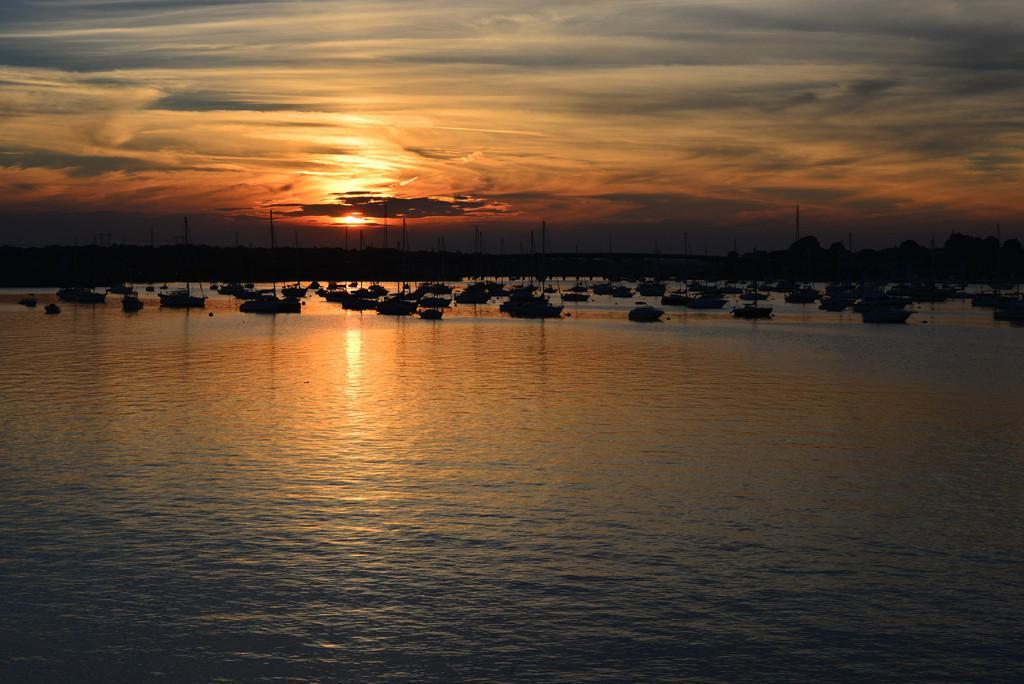Please provide a concise description of this image. In this picture there is water at the bottom side of the image and there are ships in the center of the image on the water, it seems to be the view of sun set and there is sky at the top side of the image. 